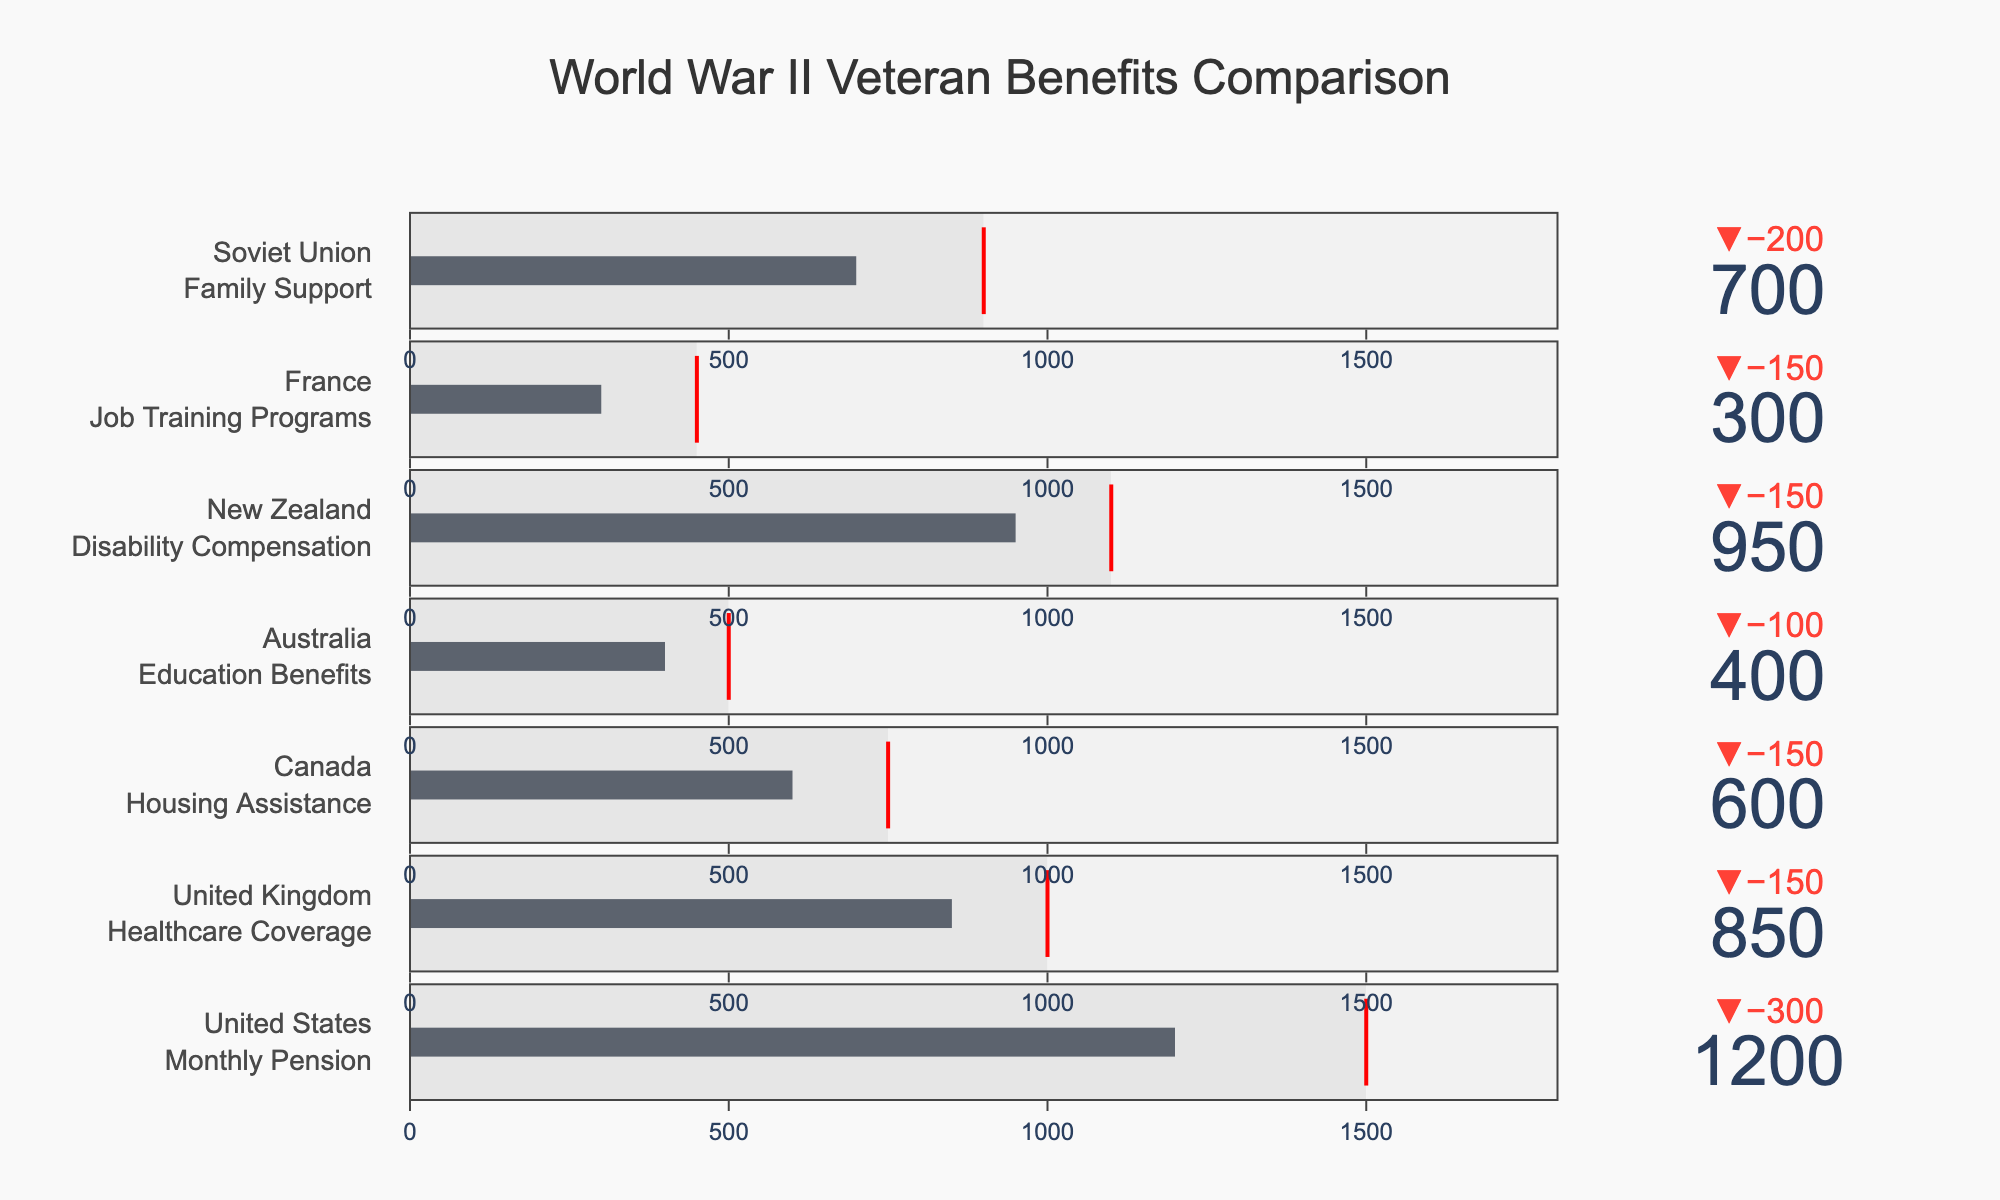Which country provides the highest actual payout for its veteran benefits? The actual payouts are listed for each country, and the highest value is 1200 from the United States.
Answer: United States Which country is closest to meeting its target payout? The difference between actual and target payouts for each country is: United States (300), United Kingdom (150), Canada (150), Australia (100), New Zealand (150), France (150), Soviet Union (200). The smallest difference is for Australia at 100.
Answer: Australia How many countries have actual payouts that exceed 700? The actual payouts exceeding 700 are: United States (1200), United Kingdom (850), New Zealand (950), and Soviet Union (700). So, 3 countries have payouts exceeding 700.
Answer: 3 What is the average target payout across all countries? The target payouts are 1500, 1000, 750, 500, 1100, 450, and 900. The sum is 6200, and the average is 6200 / 7 ≈ 885.71.
Answer: 885.71 Does any country meet or exceed its target payout? By comparing the actual and target payouts, none of the actual payouts meets or exceeds the target payouts.
Answer: No Which country has the largest shortfall between its actual and target payout? The shortfalls are: United States (300), United Kingdom (150), Canada (150), Australia (100), New Zealand (150), France (150), and Soviet Union (200). The largest shortfall is United States with 300.
Answer: United States Which benefit type has the lowest actual payout? The actual payouts sorted are: Job Training Programs (France - 300).
Answer: Job Training Programs What percentage of its target payout does France achieve? France has an actual payout of 300 and a target of 450. The percentage achieved is (300/450) * 100 = 66.67%.
Answer: 66.67% Which countries achieve at least 80% of their target payout? Calculating the percentage for each country: United States ≈ 80%, United Kingdom ≈ 85%, Canada ≈ 80%, Australia ≈ 80%, New Zealand ≈ 86.36%, France ≈ 66.67%, Soviet Union ≈ 77.78%. The countries exceeding 80% are United Kingdom and New Zealand.
Answer: United Kingdom, New Zealand Rank the countries from the highest to the lowest in terms of their actual payouts. Listing the countries by actual payouts: United States (1200), New Zealand (950), United Kingdom (850), Soviet Union (700), Canada (600), Australia (400), France (300).
Answer: United States, New Zealand, United Kingdom, Soviet Union, Canada, Australia, France 